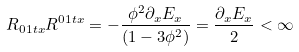Convert formula to latex. <formula><loc_0><loc_0><loc_500><loc_500>R _ { 0 1 t x } R ^ { 0 1 t x } = - \frac { { \phi } ^ { 2 } { \partial } _ { x } E _ { x } } { ( { 1 - 3 { \phi } ^ { 2 } } ) } = \frac { { \partial } _ { x } E _ { x } } { 2 } < \infty</formula> 